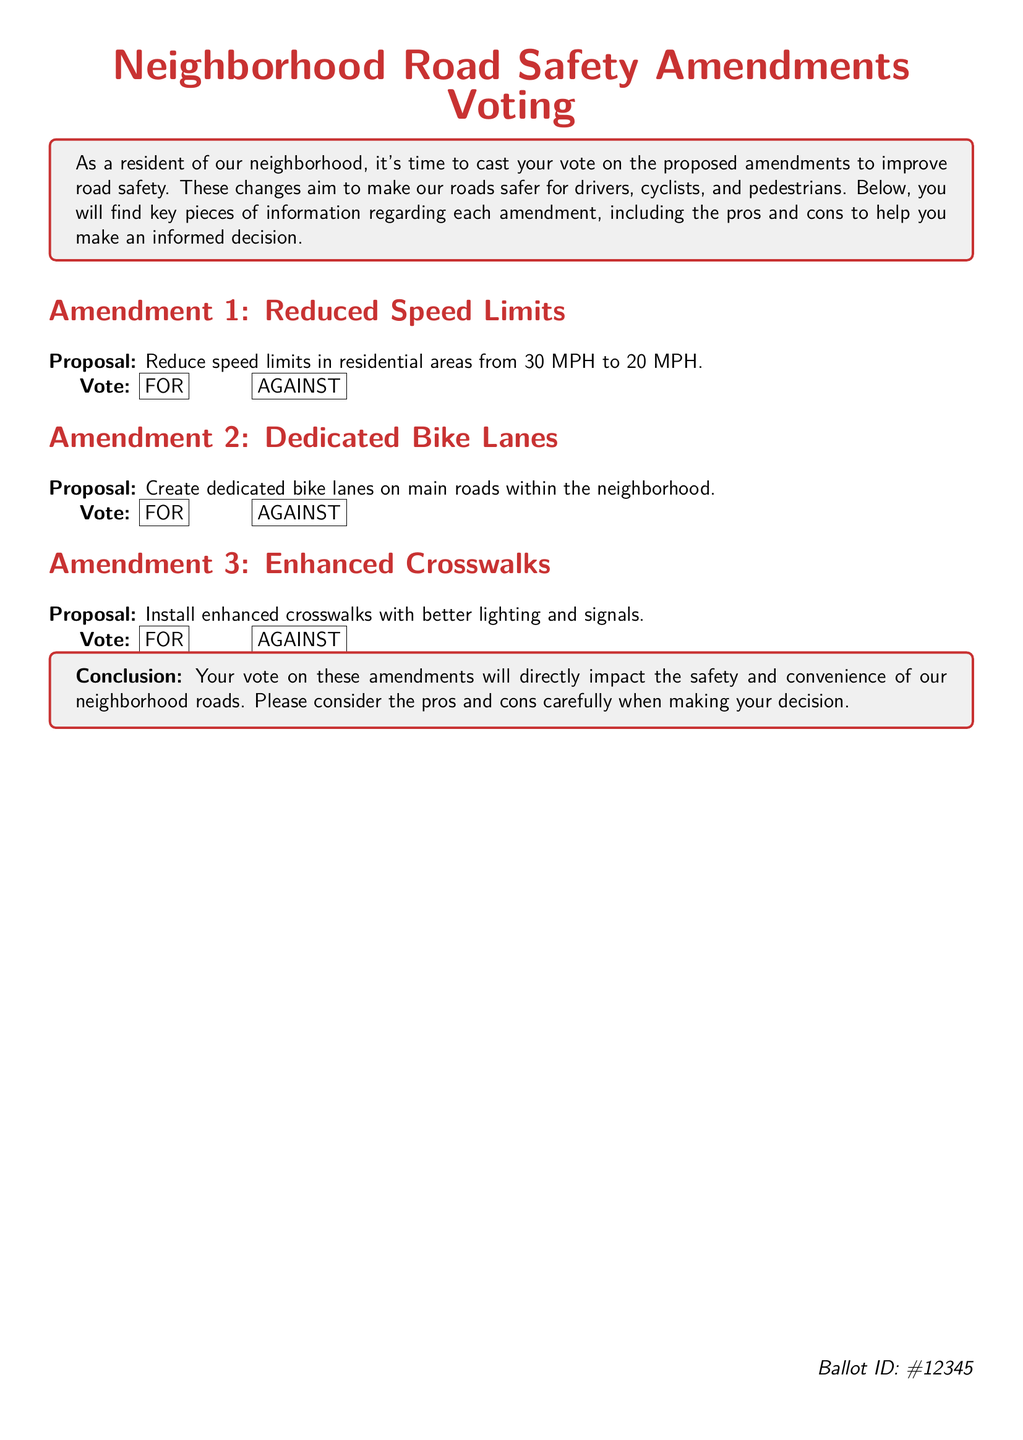What is the proposed speed limit in residential areas? The proposal suggests reducing speed limits in residential areas from 30 MPH to 20 MPH.
Answer: 20 MPH What is the main purpose of the proposed amendments? The key purpose mentioned is to improve road safety for drivers, cyclists, and pedestrians.
Answer: Improve road safety Which amendment involves enhancing crosswalks? The amendment titled "Enhanced Crosswalks" includes the proposal to install enhanced crosswalks with better lighting and signals.
Answer: Amendment 3 How many amendments are listed in the document? There are three amendments mentioned regarding neighborhood road safety in the document.
Answer: Three What is the ballot ID number? The document specifies a unique identifier for the ballot, which is indicated as #12345.
Answer: #12345 What does the proposal for Amendment 2 involve? Amendment 2 proposes creating dedicated bike lanes on main roads within the neighborhood.
Answer: Dedicated bike lanes How is the vote formatted in the document? Voting options are presented in a box format, with options labeled "FOR" and "AGAINST."
Answer: FOR and AGAINST What color is used for the section headings? The section headings are colored in a shade of red specified in the document.
Answer: Red 